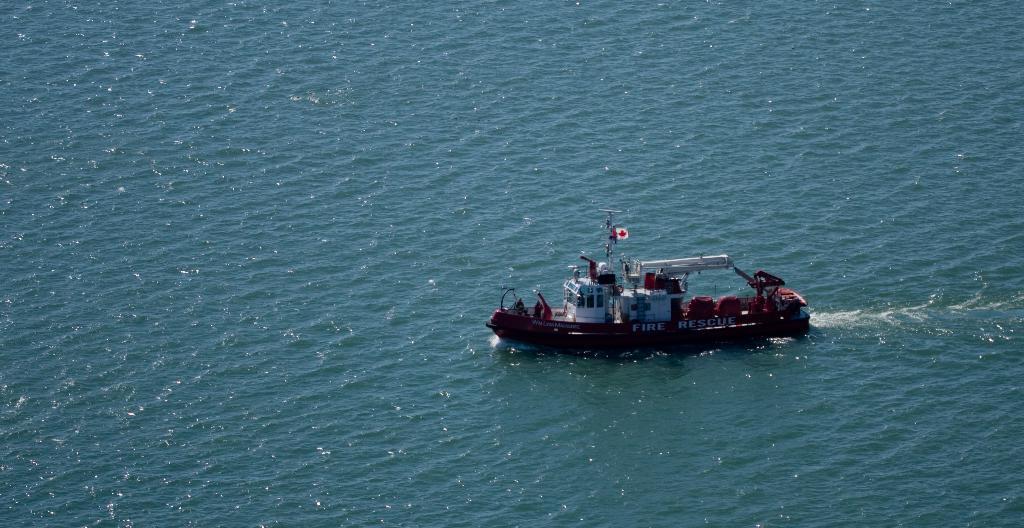Please provide a concise description of this image. Above this water there is a boat. This boat is facing towards the left side of the image. 